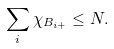Convert formula to latex. <formula><loc_0><loc_0><loc_500><loc_500>\sum _ { i } \chi _ { B _ { i + } } \leq N .</formula> 